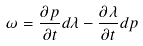Convert formula to latex. <formula><loc_0><loc_0><loc_500><loc_500>\omega = \frac { \partial p } { \partial t } d \lambda - \frac { \partial \lambda } { \partial t } d p</formula> 